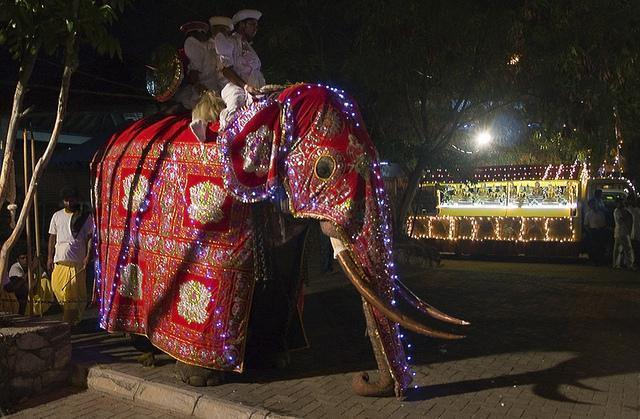Is the statement "The truck is surrounding the elephant." accurate regarding the image?
Answer yes or no. No. Is this affirmation: "The truck contains the elephant." correct?
Answer yes or no. No. 